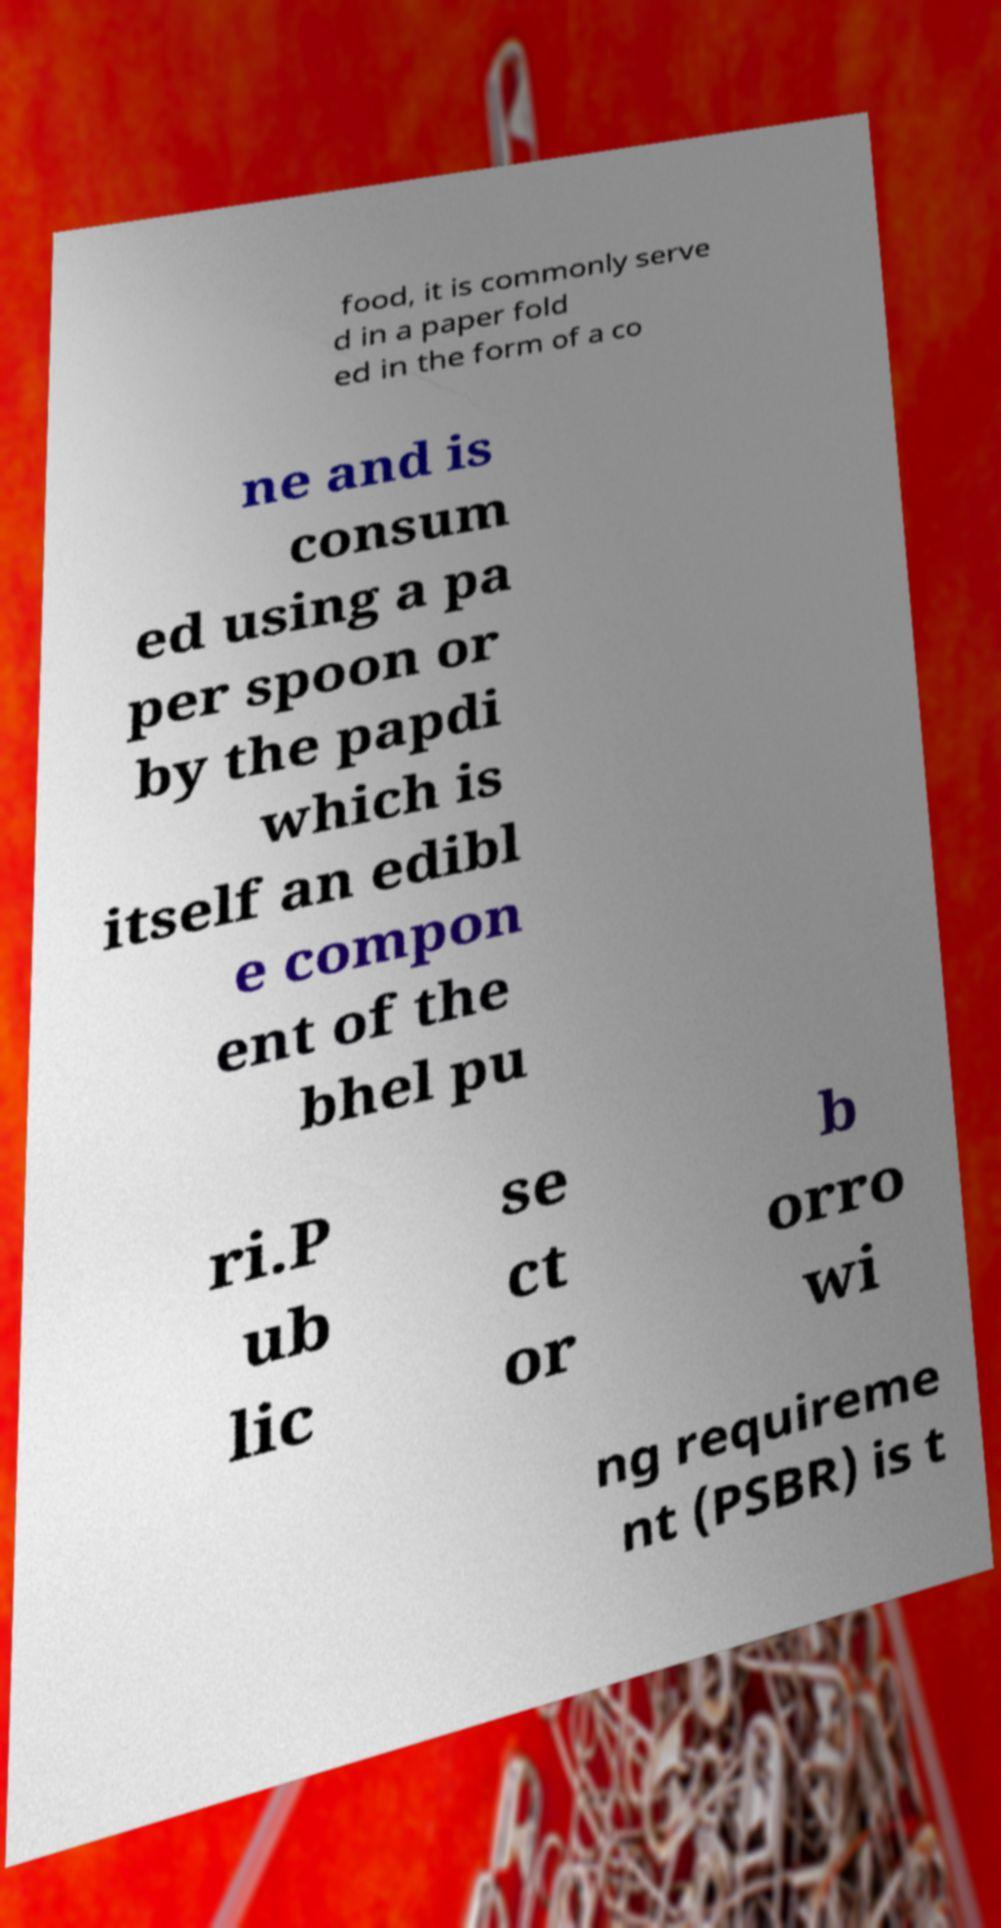I need the written content from this picture converted into text. Can you do that? food, it is commonly serve d in a paper fold ed in the form of a co ne and is consum ed using a pa per spoon or by the papdi which is itself an edibl e compon ent of the bhel pu ri.P ub lic se ct or b orro wi ng requireme nt (PSBR) is t 